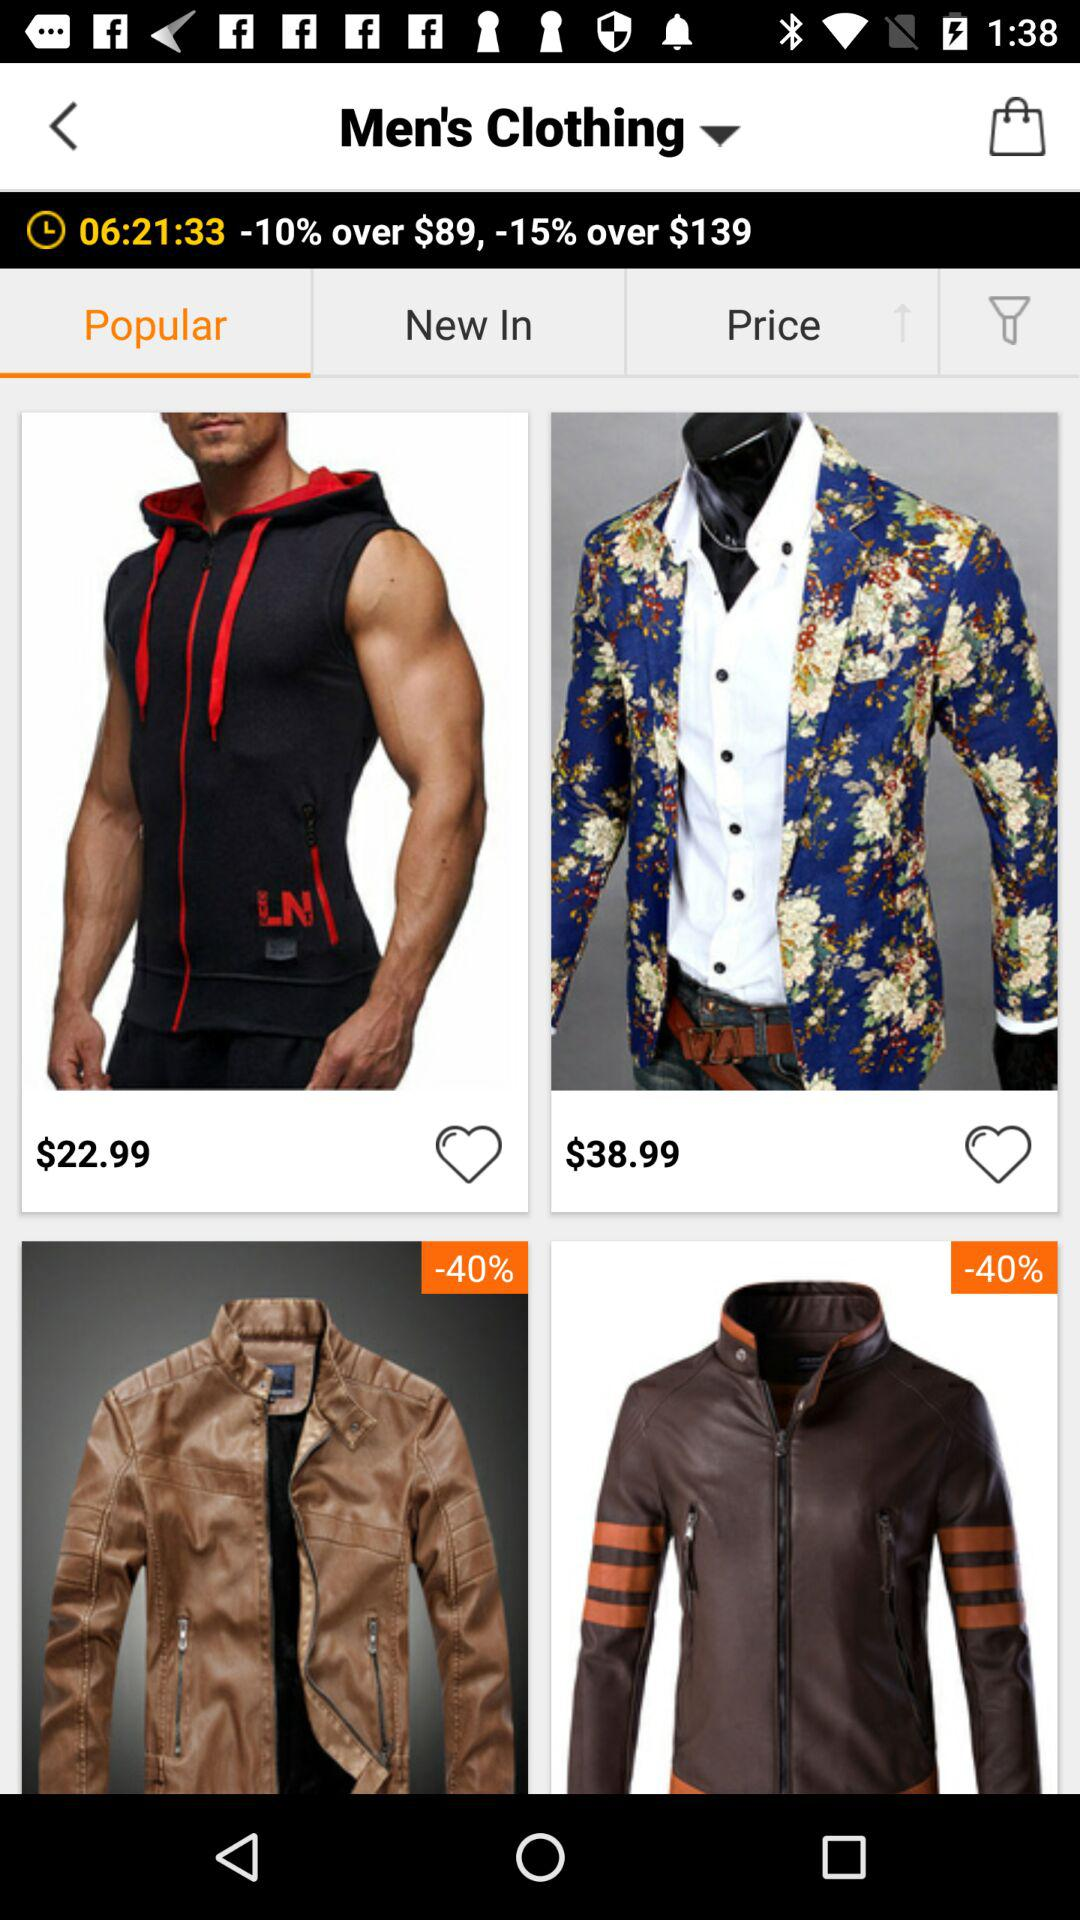How many items are on sale?
Answer the question using a single word or phrase. 2 